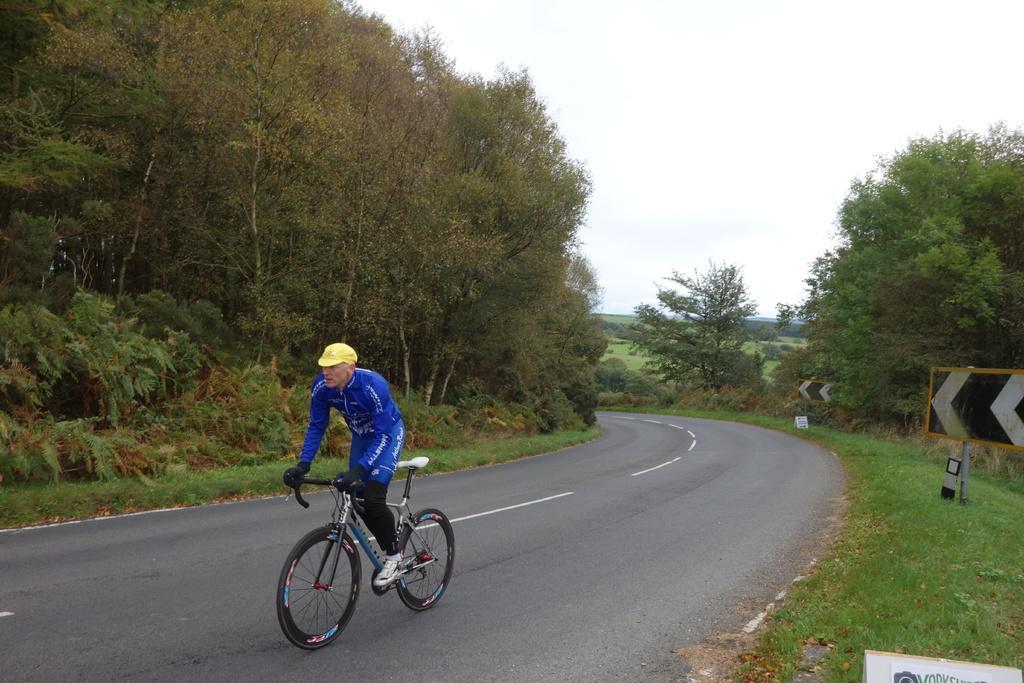Please provide a concise description of this image. In this picture we can see a man is riding a bicycle on the road. Behind the man there are trees and the sky. On the right side of the image, there is grass and there are poles with boards attached to it. 